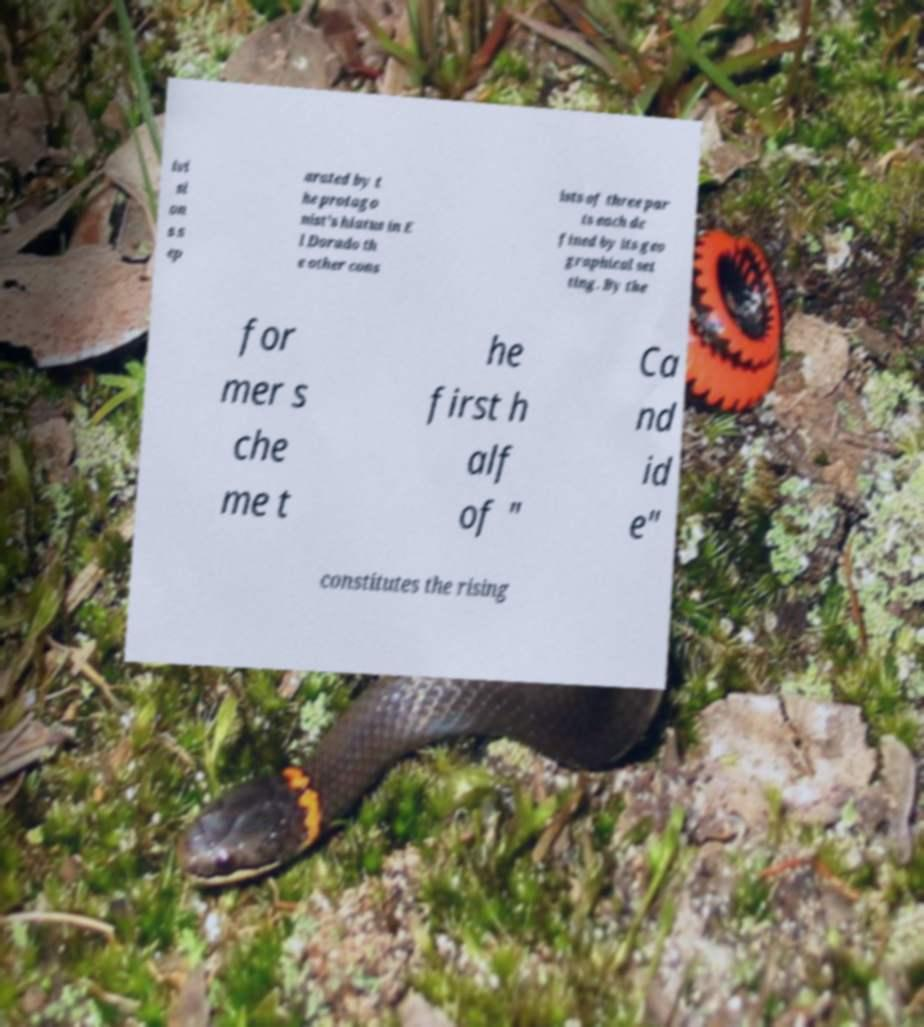There's text embedded in this image that I need extracted. Can you transcribe it verbatim? ivi si on s s ep arated by t he protago nist's hiatus in E l Dorado th e other cons ists of three par ts each de fined by its geo graphical set ting. By the for mer s che me t he first h alf of " Ca nd id e" constitutes the rising 